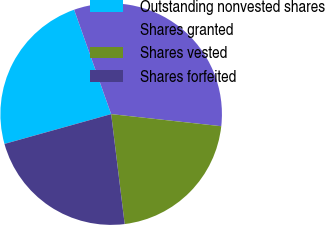Convert chart. <chart><loc_0><loc_0><loc_500><loc_500><pie_chart><fcel>Outstanding nonvested shares<fcel>Shares granted<fcel>Shares vested<fcel>Shares forfeited<nl><fcel>23.91%<fcel>32.17%<fcel>21.31%<fcel>22.61%<nl></chart> 